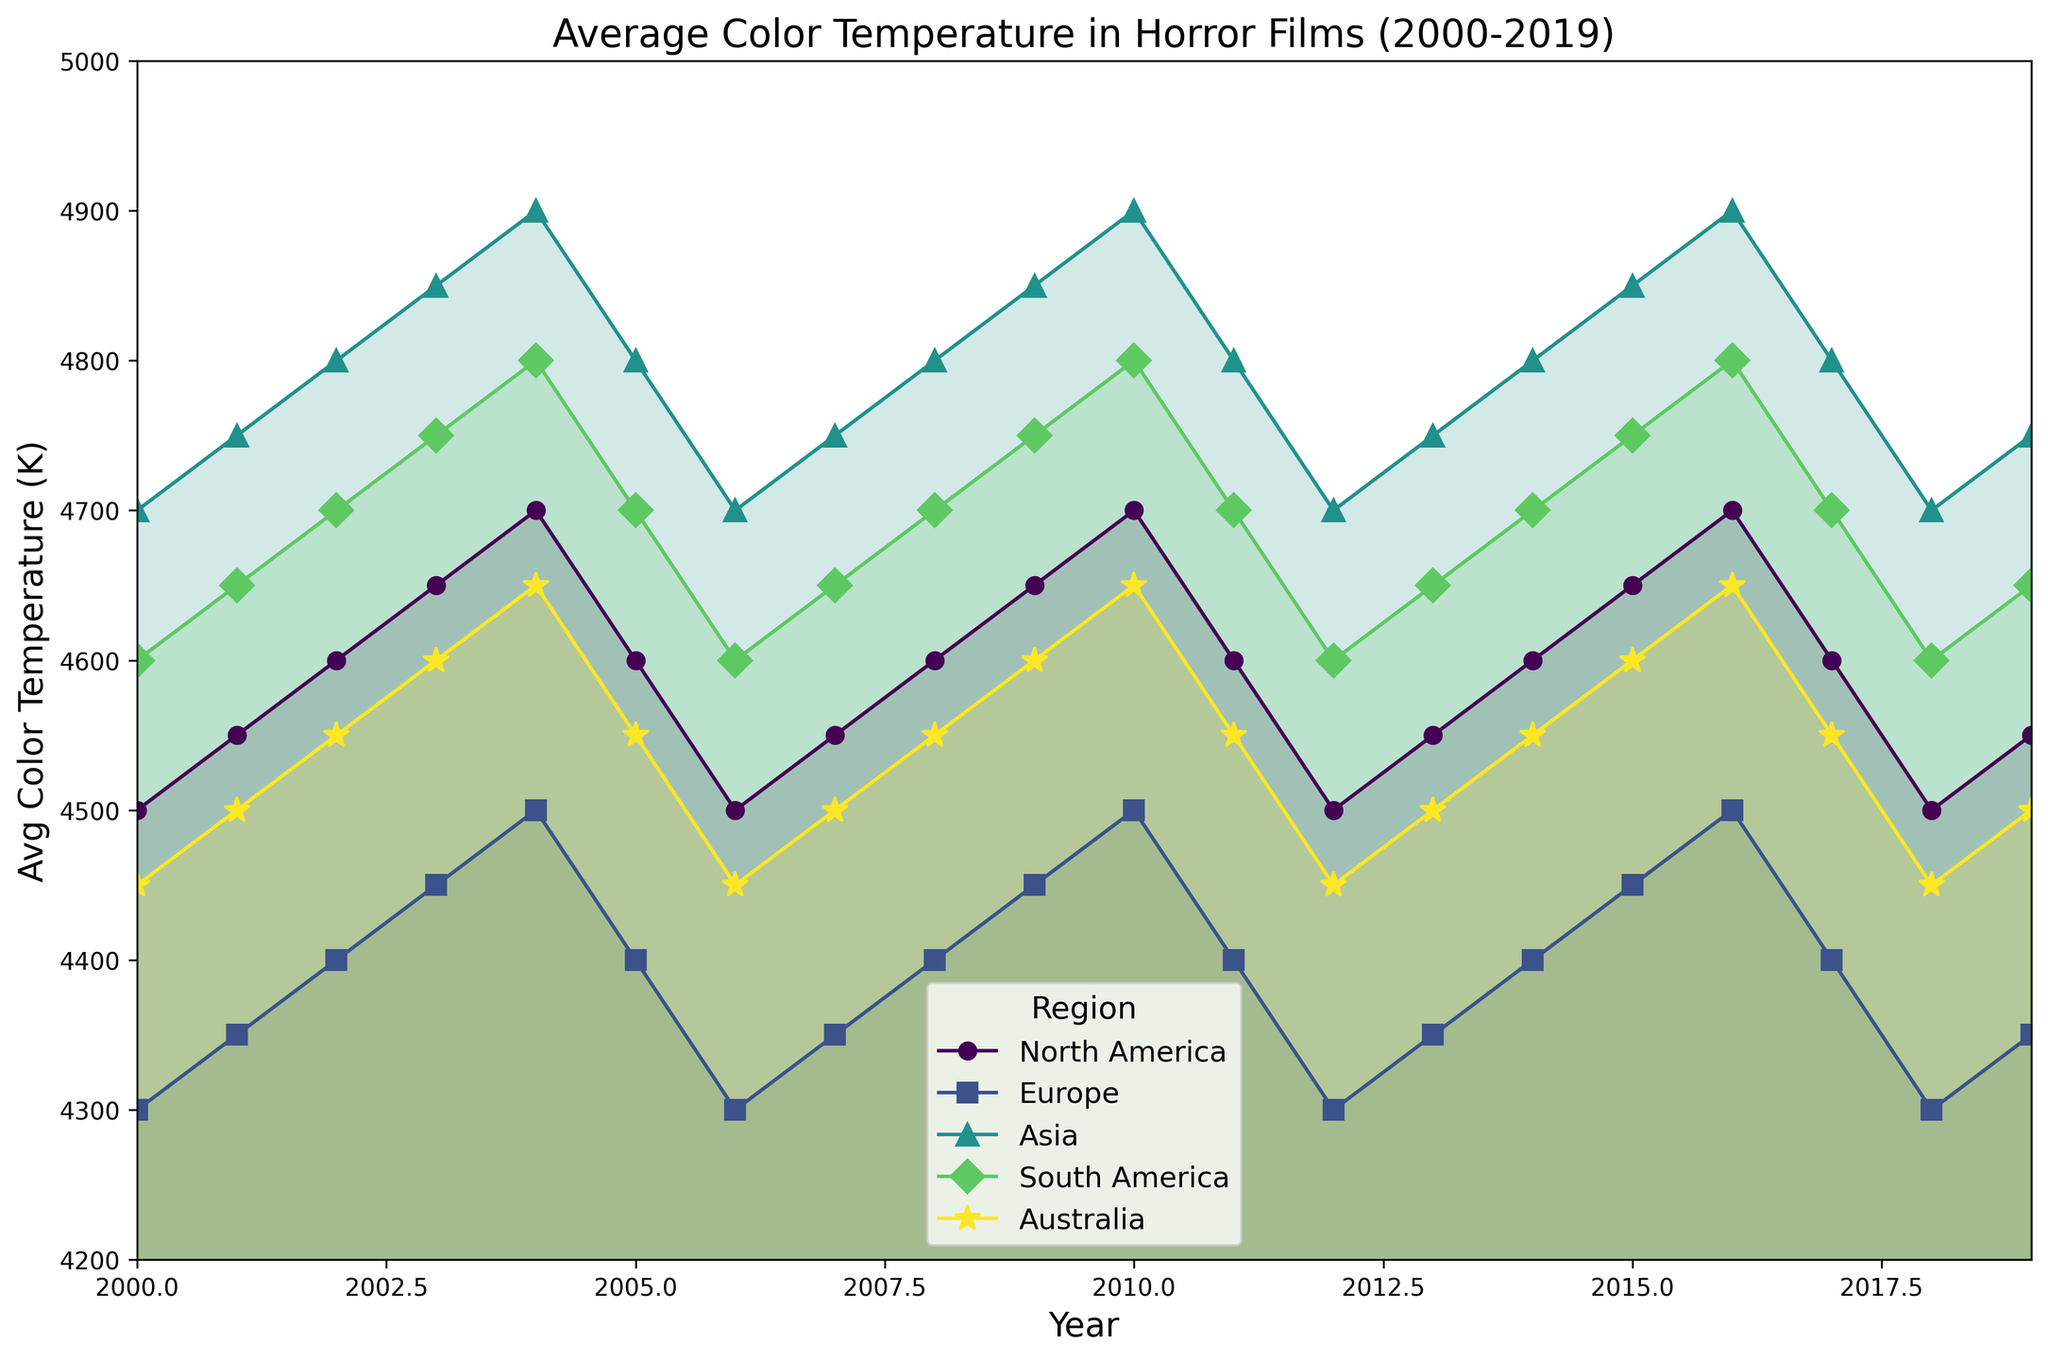What region has the highest average color temperature in 2010? By looking at the points on the plot corresponding to the year 2010, we see that Asia has the highest average color temperature around 4900K.
Answer: Asia How does the average color temperature trend in North America from 2000 to 2019? Observing the line pattern for North America, it fluctuates but generally increases from 4500K in 2000 to 4550K in 2019.
Answer: Increasing Which region has the minimum average color temperature in 2006? Checking the plot for the year 2006, Europe has the minimum average color temperature of approximately 4300K.
Answer: Europe What is the difference in average color temperature between Asia and Europe in 2004? For the year 2004, Asia's temperature is around 4900K and Europe's is approximately 4500K. The difference is 4900 - 4500 = 400K.
Answer: 400K Identify the region with the least variation in average color temperature over the years. Observing the vertical spread of the filled areas, Europe shows the least variation ranging between 4300K and 4500K throughout the period.
Answer: Europe Which year does North America have its highest average color temperature? Looking at the peaks of North America’s data, it is in 2004 and 2016, both reaching around 4700K.
Answer: 2004 and 2016 In which year did South America have an average color temperature of 4700K? By tracing the South America line on the plot, it appears that the year with 4700K is 2002, 2005, 2010, 2014, and 2017.
Answer: 2002, 2005, 2010, 2014, and 2017 How many regions have their trends marked with lines and marker symbols? Looking at the legend, all six regions (North America, Europe, Asia, South America, Australia, and Africa) are marked with lines and different marker symbols.
Answer: Six regions Which region experienced the largest drop in average color temperature from one year to the next? Reviewing the steepest slopes in the lines, Asia shows the largest drop from 4900K to 4800K between 2004 and 2005.
Answer: Asia 